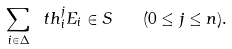<formula> <loc_0><loc_0><loc_500><loc_500>\sum _ { i \in \Delta } \ t h ^ { j } _ { i } E _ { i } \in S \quad ( 0 \leq j \leq n ) .</formula> 